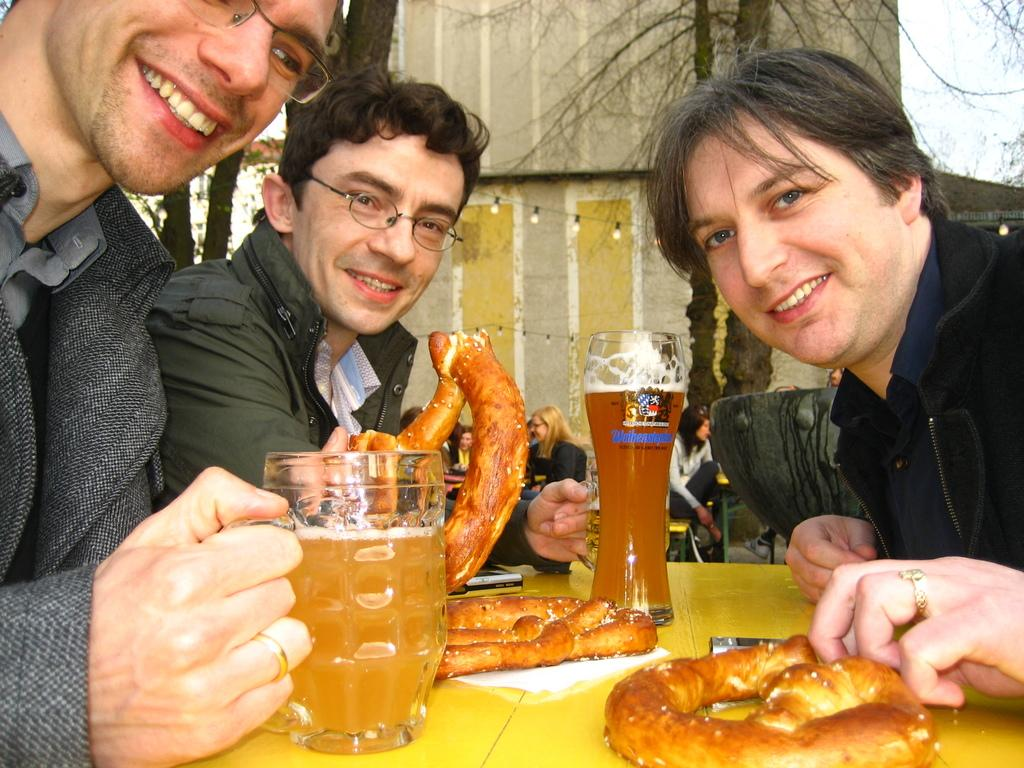What is one of the main features in the image? There is a wall in the image. Can you describe the condition of the tree in the image? There is a dry tree in the image. How many people are sitting in the image? There are three people sitting in the image. What is in front of the people? There is a table in front of the people. What type of food is on the table? There is fast food on the table. What else can be seen on the table? There are glasses on the table. What type of fact can be seen in the image? There is no fact present in the image; it is a scene with a wall, a dry tree, people, a table, fast food, and glasses. What type of game is being played in the image? There is no game being played in the image; it is a scene with a wall, a dry tree, people, a table, fast food, and glasses. 